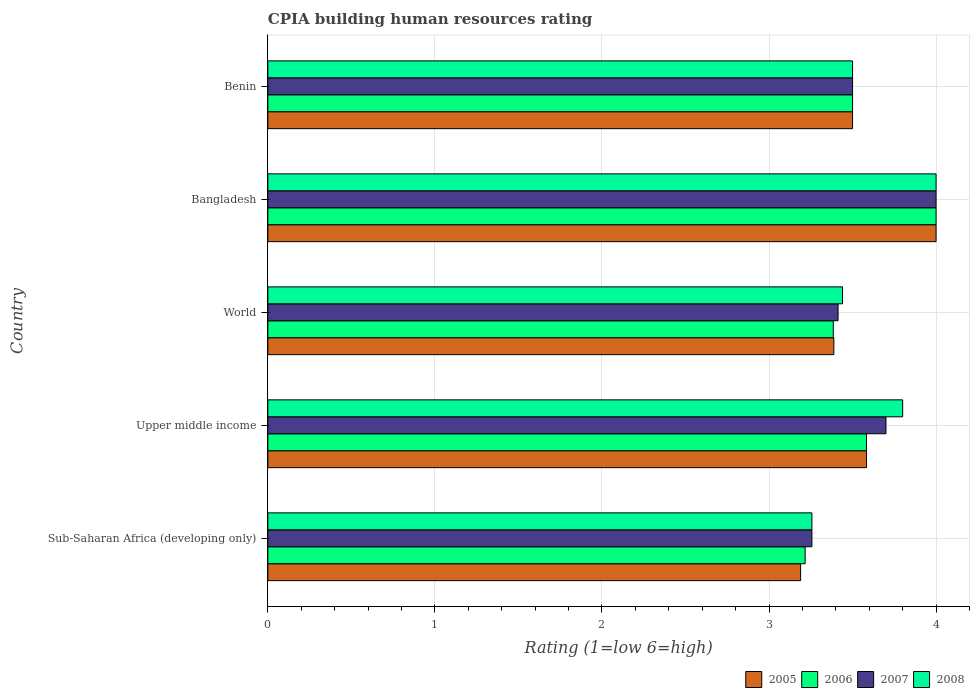How many different coloured bars are there?
Your answer should be very brief. 4. Are the number of bars on each tick of the Y-axis equal?
Offer a very short reply. Yes. How many bars are there on the 3rd tick from the top?
Your answer should be very brief. 4. What is the label of the 3rd group of bars from the top?
Provide a succinct answer. World. In how many cases, is the number of bars for a given country not equal to the number of legend labels?
Offer a very short reply. 0. What is the CPIA rating in 2008 in World?
Ensure brevity in your answer.  3.44. Across all countries, what is the maximum CPIA rating in 2006?
Your answer should be very brief. 4. Across all countries, what is the minimum CPIA rating in 2007?
Your response must be concise. 3.26. In which country was the CPIA rating in 2007 maximum?
Offer a terse response. Bangladesh. In which country was the CPIA rating in 2006 minimum?
Your response must be concise. Sub-Saharan Africa (developing only). What is the total CPIA rating in 2007 in the graph?
Keep it short and to the point. 17.87. What is the difference between the CPIA rating in 2007 in Bangladesh and that in World?
Provide a succinct answer. 0.59. What is the difference between the CPIA rating in 2005 in Sub-Saharan Africa (developing only) and the CPIA rating in 2006 in World?
Provide a succinct answer. -0.2. What is the average CPIA rating in 2005 per country?
Your response must be concise. 3.53. What is the difference between the CPIA rating in 2007 and CPIA rating in 2008 in World?
Keep it short and to the point. -0.03. What is the ratio of the CPIA rating in 2006 in Benin to that in World?
Your answer should be compact. 1.03. Is the CPIA rating in 2006 in Benin less than that in Upper middle income?
Give a very brief answer. Yes. Is the difference between the CPIA rating in 2007 in Benin and Upper middle income greater than the difference between the CPIA rating in 2008 in Benin and Upper middle income?
Your answer should be compact. Yes. What is the difference between the highest and the second highest CPIA rating in 2007?
Make the answer very short. 0.3. What is the difference between the highest and the lowest CPIA rating in 2006?
Offer a very short reply. 0.78. Is the sum of the CPIA rating in 2005 in Bangladesh and Upper middle income greater than the maximum CPIA rating in 2007 across all countries?
Keep it short and to the point. Yes. Is it the case that in every country, the sum of the CPIA rating in 2008 and CPIA rating in 2006 is greater than the sum of CPIA rating in 2007 and CPIA rating in 2005?
Your answer should be compact. No. What does the 1st bar from the bottom in Sub-Saharan Africa (developing only) represents?
Make the answer very short. 2005. How many bars are there?
Provide a succinct answer. 20. How many countries are there in the graph?
Give a very brief answer. 5. Does the graph contain grids?
Ensure brevity in your answer.  Yes. How many legend labels are there?
Your answer should be compact. 4. What is the title of the graph?
Keep it short and to the point. CPIA building human resources rating. Does "1965" appear as one of the legend labels in the graph?
Keep it short and to the point. No. What is the label or title of the X-axis?
Provide a short and direct response. Rating (1=low 6=high). What is the label or title of the Y-axis?
Your answer should be very brief. Country. What is the Rating (1=low 6=high) in 2005 in Sub-Saharan Africa (developing only)?
Offer a very short reply. 3.19. What is the Rating (1=low 6=high) of 2006 in Sub-Saharan Africa (developing only)?
Your answer should be very brief. 3.22. What is the Rating (1=low 6=high) in 2007 in Sub-Saharan Africa (developing only)?
Offer a very short reply. 3.26. What is the Rating (1=low 6=high) in 2008 in Sub-Saharan Africa (developing only)?
Provide a short and direct response. 3.26. What is the Rating (1=low 6=high) in 2005 in Upper middle income?
Give a very brief answer. 3.58. What is the Rating (1=low 6=high) in 2006 in Upper middle income?
Offer a terse response. 3.58. What is the Rating (1=low 6=high) of 2005 in World?
Provide a short and direct response. 3.39. What is the Rating (1=low 6=high) of 2006 in World?
Your answer should be very brief. 3.38. What is the Rating (1=low 6=high) in 2007 in World?
Your answer should be compact. 3.41. What is the Rating (1=low 6=high) in 2008 in World?
Offer a terse response. 3.44. What is the Rating (1=low 6=high) in 2005 in Bangladesh?
Offer a very short reply. 4. What is the Rating (1=low 6=high) of 2007 in Bangladesh?
Keep it short and to the point. 4. What is the Rating (1=low 6=high) of 2006 in Benin?
Offer a terse response. 3.5. Across all countries, what is the maximum Rating (1=low 6=high) of 2005?
Make the answer very short. 4. Across all countries, what is the maximum Rating (1=low 6=high) in 2007?
Your answer should be compact. 4. Across all countries, what is the minimum Rating (1=low 6=high) in 2005?
Your answer should be very brief. 3.19. Across all countries, what is the minimum Rating (1=low 6=high) in 2006?
Your answer should be very brief. 3.22. Across all countries, what is the minimum Rating (1=low 6=high) of 2007?
Keep it short and to the point. 3.26. Across all countries, what is the minimum Rating (1=low 6=high) in 2008?
Give a very brief answer. 3.26. What is the total Rating (1=low 6=high) in 2005 in the graph?
Offer a very short reply. 17.66. What is the total Rating (1=low 6=high) in 2006 in the graph?
Keep it short and to the point. 17.68. What is the total Rating (1=low 6=high) of 2007 in the graph?
Ensure brevity in your answer.  17.87. What is the total Rating (1=low 6=high) of 2008 in the graph?
Your response must be concise. 18. What is the difference between the Rating (1=low 6=high) of 2005 in Sub-Saharan Africa (developing only) and that in Upper middle income?
Your answer should be compact. -0.39. What is the difference between the Rating (1=low 6=high) of 2006 in Sub-Saharan Africa (developing only) and that in Upper middle income?
Make the answer very short. -0.37. What is the difference between the Rating (1=low 6=high) in 2007 in Sub-Saharan Africa (developing only) and that in Upper middle income?
Offer a terse response. -0.44. What is the difference between the Rating (1=low 6=high) of 2008 in Sub-Saharan Africa (developing only) and that in Upper middle income?
Make the answer very short. -0.54. What is the difference between the Rating (1=low 6=high) in 2005 in Sub-Saharan Africa (developing only) and that in World?
Give a very brief answer. -0.2. What is the difference between the Rating (1=low 6=high) in 2006 in Sub-Saharan Africa (developing only) and that in World?
Your response must be concise. -0.17. What is the difference between the Rating (1=low 6=high) in 2007 in Sub-Saharan Africa (developing only) and that in World?
Keep it short and to the point. -0.16. What is the difference between the Rating (1=low 6=high) of 2008 in Sub-Saharan Africa (developing only) and that in World?
Your answer should be compact. -0.18. What is the difference between the Rating (1=low 6=high) in 2005 in Sub-Saharan Africa (developing only) and that in Bangladesh?
Offer a very short reply. -0.81. What is the difference between the Rating (1=low 6=high) in 2006 in Sub-Saharan Africa (developing only) and that in Bangladesh?
Provide a succinct answer. -0.78. What is the difference between the Rating (1=low 6=high) in 2007 in Sub-Saharan Africa (developing only) and that in Bangladesh?
Your answer should be very brief. -0.74. What is the difference between the Rating (1=low 6=high) in 2008 in Sub-Saharan Africa (developing only) and that in Bangladesh?
Keep it short and to the point. -0.74. What is the difference between the Rating (1=low 6=high) of 2005 in Sub-Saharan Africa (developing only) and that in Benin?
Your response must be concise. -0.31. What is the difference between the Rating (1=low 6=high) in 2006 in Sub-Saharan Africa (developing only) and that in Benin?
Offer a very short reply. -0.28. What is the difference between the Rating (1=low 6=high) of 2007 in Sub-Saharan Africa (developing only) and that in Benin?
Ensure brevity in your answer.  -0.24. What is the difference between the Rating (1=low 6=high) in 2008 in Sub-Saharan Africa (developing only) and that in Benin?
Provide a short and direct response. -0.24. What is the difference between the Rating (1=low 6=high) of 2005 in Upper middle income and that in World?
Ensure brevity in your answer.  0.2. What is the difference between the Rating (1=low 6=high) in 2006 in Upper middle income and that in World?
Give a very brief answer. 0.2. What is the difference between the Rating (1=low 6=high) in 2007 in Upper middle income and that in World?
Offer a terse response. 0.29. What is the difference between the Rating (1=low 6=high) of 2008 in Upper middle income and that in World?
Give a very brief answer. 0.36. What is the difference between the Rating (1=low 6=high) in 2005 in Upper middle income and that in Bangladesh?
Your answer should be compact. -0.42. What is the difference between the Rating (1=low 6=high) in 2006 in Upper middle income and that in Bangladesh?
Offer a very short reply. -0.42. What is the difference between the Rating (1=low 6=high) in 2008 in Upper middle income and that in Bangladesh?
Your answer should be compact. -0.2. What is the difference between the Rating (1=low 6=high) of 2005 in Upper middle income and that in Benin?
Your answer should be very brief. 0.08. What is the difference between the Rating (1=low 6=high) in 2006 in Upper middle income and that in Benin?
Offer a terse response. 0.08. What is the difference between the Rating (1=low 6=high) of 2005 in World and that in Bangladesh?
Your response must be concise. -0.61. What is the difference between the Rating (1=low 6=high) of 2006 in World and that in Bangladesh?
Offer a terse response. -0.62. What is the difference between the Rating (1=low 6=high) in 2007 in World and that in Bangladesh?
Your response must be concise. -0.59. What is the difference between the Rating (1=low 6=high) of 2008 in World and that in Bangladesh?
Your response must be concise. -0.56. What is the difference between the Rating (1=low 6=high) of 2005 in World and that in Benin?
Make the answer very short. -0.11. What is the difference between the Rating (1=low 6=high) of 2006 in World and that in Benin?
Give a very brief answer. -0.12. What is the difference between the Rating (1=low 6=high) in 2007 in World and that in Benin?
Make the answer very short. -0.09. What is the difference between the Rating (1=low 6=high) in 2008 in World and that in Benin?
Your answer should be compact. -0.06. What is the difference between the Rating (1=low 6=high) of 2005 in Sub-Saharan Africa (developing only) and the Rating (1=low 6=high) of 2006 in Upper middle income?
Your answer should be compact. -0.39. What is the difference between the Rating (1=low 6=high) in 2005 in Sub-Saharan Africa (developing only) and the Rating (1=low 6=high) in 2007 in Upper middle income?
Keep it short and to the point. -0.51. What is the difference between the Rating (1=low 6=high) in 2005 in Sub-Saharan Africa (developing only) and the Rating (1=low 6=high) in 2008 in Upper middle income?
Your answer should be compact. -0.61. What is the difference between the Rating (1=low 6=high) of 2006 in Sub-Saharan Africa (developing only) and the Rating (1=low 6=high) of 2007 in Upper middle income?
Your answer should be compact. -0.48. What is the difference between the Rating (1=low 6=high) in 2006 in Sub-Saharan Africa (developing only) and the Rating (1=low 6=high) in 2008 in Upper middle income?
Ensure brevity in your answer.  -0.58. What is the difference between the Rating (1=low 6=high) in 2007 in Sub-Saharan Africa (developing only) and the Rating (1=low 6=high) in 2008 in Upper middle income?
Keep it short and to the point. -0.54. What is the difference between the Rating (1=low 6=high) in 2005 in Sub-Saharan Africa (developing only) and the Rating (1=low 6=high) in 2006 in World?
Provide a succinct answer. -0.2. What is the difference between the Rating (1=low 6=high) in 2005 in Sub-Saharan Africa (developing only) and the Rating (1=low 6=high) in 2007 in World?
Offer a very short reply. -0.22. What is the difference between the Rating (1=low 6=high) in 2005 in Sub-Saharan Africa (developing only) and the Rating (1=low 6=high) in 2008 in World?
Your response must be concise. -0.25. What is the difference between the Rating (1=low 6=high) in 2006 in Sub-Saharan Africa (developing only) and the Rating (1=low 6=high) in 2007 in World?
Keep it short and to the point. -0.2. What is the difference between the Rating (1=low 6=high) of 2006 in Sub-Saharan Africa (developing only) and the Rating (1=low 6=high) of 2008 in World?
Your response must be concise. -0.22. What is the difference between the Rating (1=low 6=high) of 2007 in Sub-Saharan Africa (developing only) and the Rating (1=low 6=high) of 2008 in World?
Your answer should be very brief. -0.18. What is the difference between the Rating (1=low 6=high) in 2005 in Sub-Saharan Africa (developing only) and the Rating (1=low 6=high) in 2006 in Bangladesh?
Keep it short and to the point. -0.81. What is the difference between the Rating (1=low 6=high) in 2005 in Sub-Saharan Africa (developing only) and the Rating (1=low 6=high) in 2007 in Bangladesh?
Offer a very short reply. -0.81. What is the difference between the Rating (1=low 6=high) in 2005 in Sub-Saharan Africa (developing only) and the Rating (1=low 6=high) in 2008 in Bangladesh?
Provide a short and direct response. -0.81. What is the difference between the Rating (1=low 6=high) of 2006 in Sub-Saharan Africa (developing only) and the Rating (1=low 6=high) of 2007 in Bangladesh?
Keep it short and to the point. -0.78. What is the difference between the Rating (1=low 6=high) of 2006 in Sub-Saharan Africa (developing only) and the Rating (1=low 6=high) of 2008 in Bangladesh?
Provide a short and direct response. -0.78. What is the difference between the Rating (1=low 6=high) in 2007 in Sub-Saharan Africa (developing only) and the Rating (1=low 6=high) in 2008 in Bangladesh?
Keep it short and to the point. -0.74. What is the difference between the Rating (1=low 6=high) in 2005 in Sub-Saharan Africa (developing only) and the Rating (1=low 6=high) in 2006 in Benin?
Offer a very short reply. -0.31. What is the difference between the Rating (1=low 6=high) in 2005 in Sub-Saharan Africa (developing only) and the Rating (1=low 6=high) in 2007 in Benin?
Ensure brevity in your answer.  -0.31. What is the difference between the Rating (1=low 6=high) in 2005 in Sub-Saharan Africa (developing only) and the Rating (1=low 6=high) in 2008 in Benin?
Your answer should be very brief. -0.31. What is the difference between the Rating (1=low 6=high) in 2006 in Sub-Saharan Africa (developing only) and the Rating (1=low 6=high) in 2007 in Benin?
Give a very brief answer. -0.28. What is the difference between the Rating (1=low 6=high) in 2006 in Sub-Saharan Africa (developing only) and the Rating (1=low 6=high) in 2008 in Benin?
Your response must be concise. -0.28. What is the difference between the Rating (1=low 6=high) of 2007 in Sub-Saharan Africa (developing only) and the Rating (1=low 6=high) of 2008 in Benin?
Give a very brief answer. -0.24. What is the difference between the Rating (1=low 6=high) in 2005 in Upper middle income and the Rating (1=low 6=high) in 2006 in World?
Make the answer very short. 0.2. What is the difference between the Rating (1=low 6=high) in 2005 in Upper middle income and the Rating (1=low 6=high) in 2007 in World?
Your answer should be very brief. 0.17. What is the difference between the Rating (1=low 6=high) in 2005 in Upper middle income and the Rating (1=low 6=high) in 2008 in World?
Provide a short and direct response. 0.14. What is the difference between the Rating (1=low 6=high) in 2006 in Upper middle income and the Rating (1=low 6=high) in 2007 in World?
Your answer should be very brief. 0.17. What is the difference between the Rating (1=low 6=high) of 2006 in Upper middle income and the Rating (1=low 6=high) of 2008 in World?
Your answer should be very brief. 0.14. What is the difference between the Rating (1=low 6=high) in 2007 in Upper middle income and the Rating (1=low 6=high) in 2008 in World?
Your response must be concise. 0.26. What is the difference between the Rating (1=low 6=high) of 2005 in Upper middle income and the Rating (1=low 6=high) of 2006 in Bangladesh?
Ensure brevity in your answer.  -0.42. What is the difference between the Rating (1=low 6=high) in 2005 in Upper middle income and the Rating (1=low 6=high) in 2007 in Bangladesh?
Offer a very short reply. -0.42. What is the difference between the Rating (1=low 6=high) in 2005 in Upper middle income and the Rating (1=low 6=high) in 2008 in Bangladesh?
Your answer should be compact. -0.42. What is the difference between the Rating (1=low 6=high) of 2006 in Upper middle income and the Rating (1=low 6=high) of 2007 in Bangladesh?
Keep it short and to the point. -0.42. What is the difference between the Rating (1=low 6=high) in 2006 in Upper middle income and the Rating (1=low 6=high) in 2008 in Bangladesh?
Provide a short and direct response. -0.42. What is the difference between the Rating (1=low 6=high) in 2007 in Upper middle income and the Rating (1=low 6=high) in 2008 in Bangladesh?
Ensure brevity in your answer.  -0.3. What is the difference between the Rating (1=low 6=high) in 2005 in Upper middle income and the Rating (1=low 6=high) in 2006 in Benin?
Ensure brevity in your answer.  0.08. What is the difference between the Rating (1=low 6=high) in 2005 in Upper middle income and the Rating (1=low 6=high) in 2007 in Benin?
Offer a terse response. 0.08. What is the difference between the Rating (1=low 6=high) of 2005 in Upper middle income and the Rating (1=low 6=high) of 2008 in Benin?
Offer a terse response. 0.08. What is the difference between the Rating (1=low 6=high) of 2006 in Upper middle income and the Rating (1=low 6=high) of 2007 in Benin?
Your response must be concise. 0.08. What is the difference between the Rating (1=low 6=high) of 2006 in Upper middle income and the Rating (1=low 6=high) of 2008 in Benin?
Your answer should be very brief. 0.08. What is the difference between the Rating (1=low 6=high) of 2007 in Upper middle income and the Rating (1=low 6=high) of 2008 in Benin?
Make the answer very short. 0.2. What is the difference between the Rating (1=low 6=high) in 2005 in World and the Rating (1=low 6=high) in 2006 in Bangladesh?
Your answer should be very brief. -0.61. What is the difference between the Rating (1=low 6=high) in 2005 in World and the Rating (1=low 6=high) in 2007 in Bangladesh?
Provide a short and direct response. -0.61. What is the difference between the Rating (1=low 6=high) of 2005 in World and the Rating (1=low 6=high) of 2008 in Bangladesh?
Provide a short and direct response. -0.61. What is the difference between the Rating (1=low 6=high) in 2006 in World and the Rating (1=low 6=high) in 2007 in Bangladesh?
Ensure brevity in your answer.  -0.62. What is the difference between the Rating (1=low 6=high) in 2006 in World and the Rating (1=low 6=high) in 2008 in Bangladesh?
Your response must be concise. -0.62. What is the difference between the Rating (1=low 6=high) in 2007 in World and the Rating (1=low 6=high) in 2008 in Bangladesh?
Offer a very short reply. -0.59. What is the difference between the Rating (1=low 6=high) of 2005 in World and the Rating (1=low 6=high) of 2006 in Benin?
Offer a very short reply. -0.11. What is the difference between the Rating (1=low 6=high) of 2005 in World and the Rating (1=low 6=high) of 2007 in Benin?
Offer a terse response. -0.11. What is the difference between the Rating (1=low 6=high) in 2005 in World and the Rating (1=low 6=high) in 2008 in Benin?
Keep it short and to the point. -0.11. What is the difference between the Rating (1=low 6=high) in 2006 in World and the Rating (1=low 6=high) in 2007 in Benin?
Give a very brief answer. -0.12. What is the difference between the Rating (1=low 6=high) of 2006 in World and the Rating (1=low 6=high) of 2008 in Benin?
Provide a short and direct response. -0.12. What is the difference between the Rating (1=low 6=high) of 2007 in World and the Rating (1=low 6=high) of 2008 in Benin?
Your response must be concise. -0.09. What is the difference between the Rating (1=low 6=high) in 2005 in Bangladesh and the Rating (1=low 6=high) in 2006 in Benin?
Your response must be concise. 0.5. What is the difference between the Rating (1=low 6=high) in 2006 in Bangladesh and the Rating (1=low 6=high) in 2007 in Benin?
Your response must be concise. 0.5. What is the difference between the Rating (1=low 6=high) in 2006 in Bangladesh and the Rating (1=low 6=high) in 2008 in Benin?
Ensure brevity in your answer.  0.5. What is the average Rating (1=low 6=high) in 2005 per country?
Your answer should be very brief. 3.53. What is the average Rating (1=low 6=high) in 2006 per country?
Your answer should be compact. 3.54. What is the average Rating (1=low 6=high) in 2007 per country?
Your answer should be very brief. 3.57. What is the average Rating (1=low 6=high) of 2008 per country?
Keep it short and to the point. 3.6. What is the difference between the Rating (1=low 6=high) of 2005 and Rating (1=low 6=high) of 2006 in Sub-Saharan Africa (developing only)?
Your response must be concise. -0.03. What is the difference between the Rating (1=low 6=high) in 2005 and Rating (1=low 6=high) in 2007 in Sub-Saharan Africa (developing only)?
Your answer should be compact. -0.07. What is the difference between the Rating (1=low 6=high) of 2005 and Rating (1=low 6=high) of 2008 in Sub-Saharan Africa (developing only)?
Your answer should be very brief. -0.07. What is the difference between the Rating (1=low 6=high) in 2006 and Rating (1=low 6=high) in 2007 in Sub-Saharan Africa (developing only)?
Offer a terse response. -0.04. What is the difference between the Rating (1=low 6=high) in 2006 and Rating (1=low 6=high) in 2008 in Sub-Saharan Africa (developing only)?
Give a very brief answer. -0.04. What is the difference between the Rating (1=low 6=high) of 2005 and Rating (1=low 6=high) of 2007 in Upper middle income?
Provide a succinct answer. -0.12. What is the difference between the Rating (1=low 6=high) of 2005 and Rating (1=low 6=high) of 2008 in Upper middle income?
Keep it short and to the point. -0.22. What is the difference between the Rating (1=low 6=high) in 2006 and Rating (1=low 6=high) in 2007 in Upper middle income?
Your answer should be compact. -0.12. What is the difference between the Rating (1=low 6=high) in 2006 and Rating (1=low 6=high) in 2008 in Upper middle income?
Provide a succinct answer. -0.22. What is the difference between the Rating (1=low 6=high) of 2007 and Rating (1=low 6=high) of 2008 in Upper middle income?
Your response must be concise. -0.1. What is the difference between the Rating (1=low 6=high) of 2005 and Rating (1=low 6=high) of 2006 in World?
Make the answer very short. 0. What is the difference between the Rating (1=low 6=high) of 2005 and Rating (1=low 6=high) of 2007 in World?
Ensure brevity in your answer.  -0.03. What is the difference between the Rating (1=low 6=high) of 2005 and Rating (1=low 6=high) of 2008 in World?
Provide a short and direct response. -0.05. What is the difference between the Rating (1=low 6=high) in 2006 and Rating (1=low 6=high) in 2007 in World?
Keep it short and to the point. -0.03. What is the difference between the Rating (1=low 6=high) in 2006 and Rating (1=low 6=high) in 2008 in World?
Provide a succinct answer. -0.06. What is the difference between the Rating (1=low 6=high) of 2007 and Rating (1=low 6=high) of 2008 in World?
Give a very brief answer. -0.03. What is the difference between the Rating (1=low 6=high) in 2005 and Rating (1=low 6=high) in 2007 in Bangladesh?
Offer a terse response. 0. What is the difference between the Rating (1=low 6=high) of 2006 and Rating (1=low 6=high) of 2008 in Bangladesh?
Your answer should be very brief. 0. What is the difference between the Rating (1=low 6=high) of 2005 and Rating (1=low 6=high) of 2006 in Benin?
Your answer should be very brief. 0. What is the ratio of the Rating (1=low 6=high) in 2005 in Sub-Saharan Africa (developing only) to that in Upper middle income?
Give a very brief answer. 0.89. What is the ratio of the Rating (1=low 6=high) in 2006 in Sub-Saharan Africa (developing only) to that in Upper middle income?
Your answer should be very brief. 0.9. What is the ratio of the Rating (1=low 6=high) of 2007 in Sub-Saharan Africa (developing only) to that in Upper middle income?
Make the answer very short. 0.88. What is the ratio of the Rating (1=low 6=high) in 2008 in Sub-Saharan Africa (developing only) to that in Upper middle income?
Give a very brief answer. 0.86. What is the ratio of the Rating (1=low 6=high) in 2005 in Sub-Saharan Africa (developing only) to that in World?
Provide a succinct answer. 0.94. What is the ratio of the Rating (1=low 6=high) in 2006 in Sub-Saharan Africa (developing only) to that in World?
Keep it short and to the point. 0.95. What is the ratio of the Rating (1=low 6=high) of 2007 in Sub-Saharan Africa (developing only) to that in World?
Give a very brief answer. 0.95. What is the ratio of the Rating (1=low 6=high) in 2008 in Sub-Saharan Africa (developing only) to that in World?
Keep it short and to the point. 0.95. What is the ratio of the Rating (1=low 6=high) of 2005 in Sub-Saharan Africa (developing only) to that in Bangladesh?
Ensure brevity in your answer.  0.8. What is the ratio of the Rating (1=low 6=high) in 2006 in Sub-Saharan Africa (developing only) to that in Bangladesh?
Offer a terse response. 0.8. What is the ratio of the Rating (1=low 6=high) in 2007 in Sub-Saharan Africa (developing only) to that in Bangladesh?
Provide a short and direct response. 0.81. What is the ratio of the Rating (1=low 6=high) of 2008 in Sub-Saharan Africa (developing only) to that in Bangladesh?
Your response must be concise. 0.81. What is the ratio of the Rating (1=low 6=high) in 2005 in Sub-Saharan Africa (developing only) to that in Benin?
Provide a succinct answer. 0.91. What is the ratio of the Rating (1=low 6=high) of 2006 in Sub-Saharan Africa (developing only) to that in Benin?
Offer a very short reply. 0.92. What is the ratio of the Rating (1=low 6=high) of 2007 in Sub-Saharan Africa (developing only) to that in Benin?
Your answer should be compact. 0.93. What is the ratio of the Rating (1=low 6=high) of 2008 in Sub-Saharan Africa (developing only) to that in Benin?
Ensure brevity in your answer.  0.93. What is the ratio of the Rating (1=low 6=high) in 2005 in Upper middle income to that in World?
Provide a succinct answer. 1.06. What is the ratio of the Rating (1=low 6=high) in 2006 in Upper middle income to that in World?
Your answer should be very brief. 1.06. What is the ratio of the Rating (1=low 6=high) in 2007 in Upper middle income to that in World?
Make the answer very short. 1.08. What is the ratio of the Rating (1=low 6=high) of 2008 in Upper middle income to that in World?
Ensure brevity in your answer.  1.1. What is the ratio of the Rating (1=low 6=high) in 2005 in Upper middle income to that in Bangladesh?
Keep it short and to the point. 0.9. What is the ratio of the Rating (1=low 6=high) of 2006 in Upper middle income to that in Bangladesh?
Offer a very short reply. 0.9. What is the ratio of the Rating (1=low 6=high) of 2007 in Upper middle income to that in Bangladesh?
Your response must be concise. 0.93. What is the ratio of the Rating (1=low 6=high) in 2008 in Upper middle income to that in Bangladesh?
Your response must be concise. 0.95. What is the ratio of the Rating (1=low 6=high) of 2005 in Upper middle income to that in Benin?
Provide a succinct answer. 1.02. What is the ratio of the Rating (1=low 6=high) in 2006 in Upper middle income to that in Benin?
Ensure brevity in your answer.  1.02. What is the ratio of the Rating (1=low 6=high) in 2007 in Upper middle income to that in Benin?
Make the answer very short. 1.06. What is the ratio of the Rating (1=low 6=high) of 2008 in Upper middle income to that in Benin?
Ensure brevity in your answer.  1.09. What is the ratio of the Rating (1=low 6=high) of 2005 in World to that in Bangladesh?
Provide a short and direct response. 0.85. What is the ratio of the Rating (1=low 6=high) of 2006 in World to that in Bangladesh?
Offer a very short reply. 0.85. What is the ratio of the Rating (1=low 6=high) in 2007 in World to that in Bangladesh?
Provide a succinct answer. 0.85. What is the ratio of the Rating (1=low 6=high) in 2008 in World to that in Bangladesh?
Your response must be concise. 0.86. What is the ratio of the Rating (1=low 6=high) of 2007 in World to that in Benin?
Make the answer very short. 0.98. What is the ratio of the Rating (1=low 6=high) of 2008 in World to that in Benin?
Provide a succinct answer. 0.98. What is the difference between the highest and the second highest Rating (1=low 6=high) in 2005?
Offer a very short reply. 0.42. What is the difference between the highest and the second highest Rating (1=low 6=high) in 2006?
Provide a short and direct response. 0.42. What is the difference between the highest and the second highest Rating (1=low 6=high) of 2007?
Offer a terse response. 0.3. What is the difference between the highest and the second highest Rating (1=low 6=high) in 2008?
Keep it short and to the point. 0.2. What is the difference between the highest and the lowest Rating (1=low 6=high) of 2005?
Provide a short and direct response. 0.81. What is the difference between the highest and the lowest Rating (1=low 6=high) in 2006?
Provide a short and direct response. 0.78. What is the difference between the highest and the lowest Rating (1=low 6=high) of 2007?
Ensure brevity in your answer.  0.74. What is the difference between the highest and the lowest Rating (1=low 6=high) of 2008?
Offer a very short reply. 0.74. 